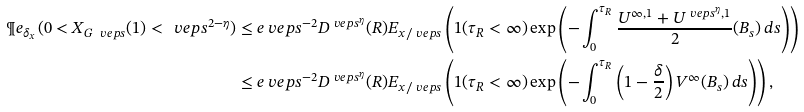<formula> <loc_0><loc_0><loc_500><loc_500>\P e _ { \delta _ { x } } ( 0 < X _ { G _ { \ } v e p s } ( 1 ) < \ v e p s ^ { 2 - \eta } ) & \leq e \ v e p s ^ { - 2 } D ^ { \ v e p s ^ { \eta } } ( R ) E _ { x / \ v e p s } \left ( 1 ( \tau _ { R } < \infty ) \exp \left ( - \int _ { 0 } ^ { \tau _ { R } } \frac { U ^ { \infty , 1 } + U ^ { \ v e p s ^ { \eta } , 1 } } { 2 } ( B _ { s } ) \, d s \right ) \right ) \\ & \leq e \ v e p s ^ { - 2 } D ^ { \ v e p s ^ { \eta } } ( R ) E _ { x / \ v e p s } \left ( 1 ( \tau _ { R } < \infty ) \exp \left ( - \int _ { 0 } ^ { \tau _ { R } } \left ( 1 - \frac { \delta } { 2 } \right ) V ^ { \infty } ( B _ { s } ) \, d s \right ) \right ) ,</formula> 